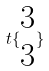<formula> <loc_0><loc_0><loc_500><loc_500>t \{ \begin{matrix} 3 \\ 3 \end{matrix} \}</formula> 